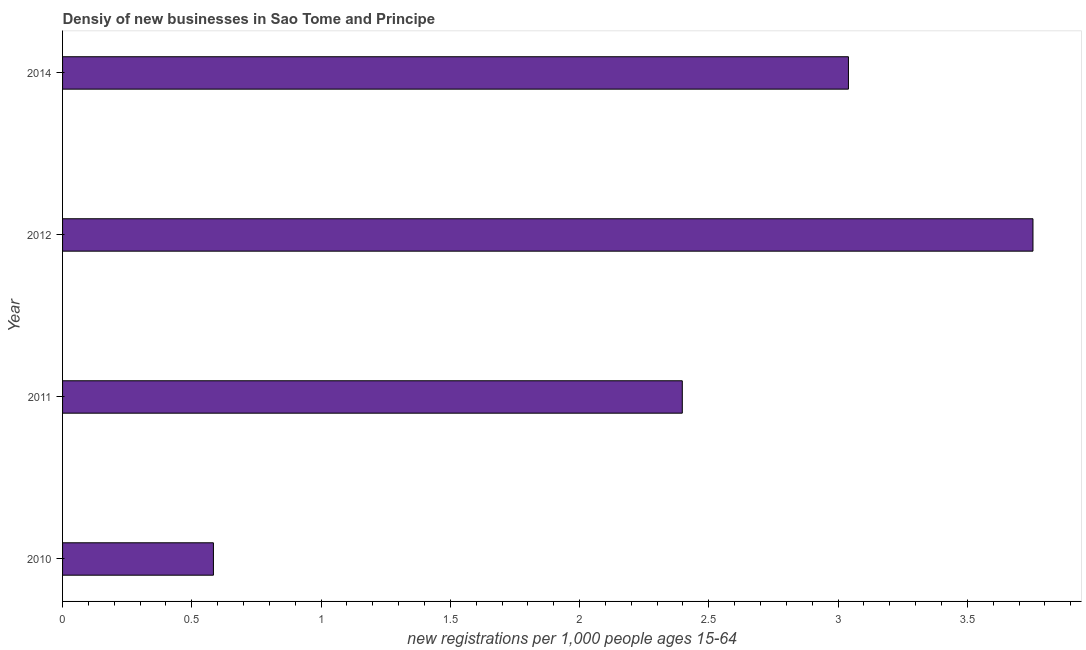Does the graph contain any zero values?
Make the answer very short. No. What is the title of the graph?
Make the answer very short. Densiy of new businesses in Sao Tome and Principe. What is the label or title of the X-axis?
Provide a succinct answer. New registrations per 1,0 people ages 15-64. What is the density of new business in 2011?
Ensure brevity in your answer.  2.4. Across all years, what is the maximum density of new business?
Make the answer very short. 3.75. Across all years, what is the minimum density of new business?
Provide a succinct answer. 0.58. What is the sum of the density of new business?
Provide a short and direct response. 9.77. What is the difference between the density of new business in 2010 and 2011?
Provide a short and direct response. -1.81. What is the average density of new business per year?
Provide a short and direct response. 2.44. What is the median density of new business?
Offer a very short reply. 2.72. In how many years, is the density of new business greater than 3.1 ?
Keep it short and to the point. 1. Do a majority of the years between 2010 and 2012 (inclusive) have density of new business greater than 1.1 ?
Your response must be concise. Yes. What is the ratio of the density of new business in 2010 to that in 2014?
Give a very brief answer. 0.19. Is the density of new business in 2011 less than that in 2012?
Keep it short and to the point. Yes. Is the difference between the density of new business in 2012 and 2014 greater than the difference between any two years?
Provide a short and direct response. No. What is the difference between the highest and the second highest density of new business?
Ensure brevity in your answer.  0.71. Is the sum of the density of new business in 2011 and 2012 greater than the maximum density of new business across all years?
Offer a terse response. Yes. What is the difference between the highest and the lowest density of new business?
Your answer should be very brief. 3.17. In how many years, is the density of new business greater than the average density of new business taken over all years?
Make the answer very short. 2. How many years are there in the graph?
Your answer should be compact. 4. Are the values on the major ticks of X-axis written in scientific E-notation?
Keep it short and to the point. No. What is the new registrations per 1,000 people ages 15-64 of 2010?
Keep it short and to the point. 0.58. What is the new registrations per 1,000 people ages 15-64 in 2011?
Provide a succinct answer. 2.4. What is the new registrations per 1,000 people ages 15-64 in 2012?
Keep it short and to the point. 3.75. What is the new registrations per 1,000 people ages 15-64 in 2014?
Your response must be concise. 3.04. What is the difference between the new registrations per 1,000 people ages 15-64 in 2010 and 2011?
Your answer should be very brief. -1.81. What is the difference between the new registrations per 1,000 people ages 15-64 in 2010 and 2012?
Offer a terse response. -3.17. What is the difference between the new registrations per 1,000 people ages 15-64 in 2010 and 2014?
Keep it short and to the point. -2.46. What is the difference between the new registrations per 1,000 people ages 15-64 in 2011 and 2012?
Give a very brief answer. -1.36. What is the difference between the new registrations per 1,000 people ages 15-64 in 2011 and 2014?
Offer a very short reply. -0.64. What is the difference between the new registrations per 1,000 people ages 15-64 in 2012 and 2014?
Give a very brief answer. 0.71. What is the ratio of the new registrations per 1,000 people ages 15-64 in 2010 to that in 2011?
Your answer should be compact. 0.24. What is the ratio of the new registrations per 1,000 people ages 15-64 in 2010 to that in 2012?
Provide a short and direct response. 0.15. What is the ratio of the new registrations per 1,000 people ages 15-64 in 2010 to that in 2014?
Your answer should be compact. 0.19. What is the ratio of the new registrations per 1,000 people ages 15-64 in 2011 to that in 2012?
Offer a very short reply. 0.64. What is the ratio of the new registrations per 1,000 people ages 15-64 in 2011 to that in 2014?
Ensure brevity in your answer.  0.79. What is the ratio of the new registrations per 1,000 people ages 15-64 in 2012 to that in 2014?
Keep it short and to the point. 1.24. 